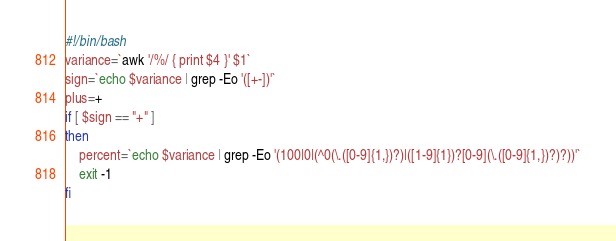Convert code to text. <code><loc_0><loc_0><loc_500><loc_500><_Bash_>#!/bin/bash
variance=`awk '/%/ { print $4 }' $1`
sign=`echo $variance | grep -Eo '([+-])'`
plus=+
if [ $sign == "+" ]
then
	percent=`echo $variance | grep -Eo '(100|0|(^0(\.([0-9]{1,})?)|([1-9]{1})?[0-9](\.([0-9]{1,})?)?))'`
	exit -1
fi

</code> 